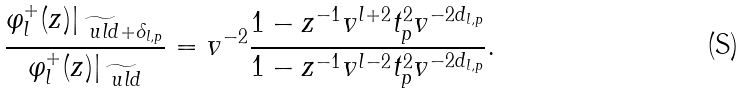Convert formula to latex. <formula><loc_0><loc_0><loc_500><loc_500>\frac { \varphi _ { l } ^ { + } ( z ) | _ { \widetilde { \ u l { d } } + \delta _ { l , p } } } { \varphi _ { l } ^ { + } ( z ) | _ { \widetilde { \ u l { d } } } } = v ^ { - 2 } \frac { 1 - z ^ { - 1 } v ^ { l + 2 } t _ { p } ^ { 2 } v ^ { - 2 d _ { l , p } } } { 1 - z ^ { - 1 } v ^ { l - 2 } t _ { p } ^ { 2 } v ^ { - 2 d _ { l , p } } } .</formula> 